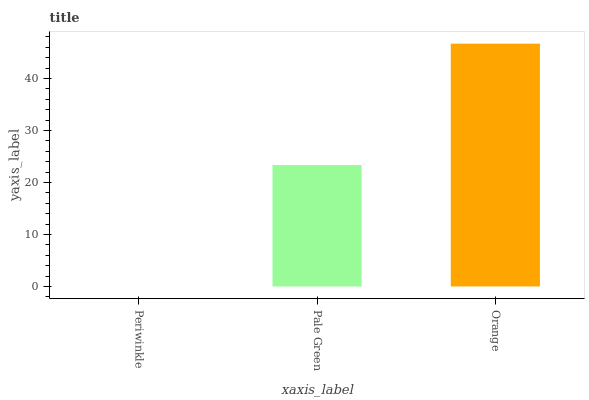Is Periwinkle the minimum?
Answer yes or no. Yes. Is Orange the maximum?
Answer yes or no. Yes. Is Pale Green the minimum?
Answer yes or no. No. Is Pale Green the maximum?
Answer yes or no. No. Is Pale Green greater than Periwinkle?
Answer yes or no. Yes. Is Periwinkle less than Pale Green?
Answer yes or no. Yes. Is Periwinkle greater than Pale Green?
Answer yes or no. No. Is Pale Green less than Periwinkle?
Answer yes or no. No. Is Pale Green the high median?
Answer yes or no. Yes. Is Pale Green the low median?
Answer yes or no. Yes. Is Periwinkle the high median?
Answer yes or no. No. Is Orange the low median?
Answer yes or no. No. 